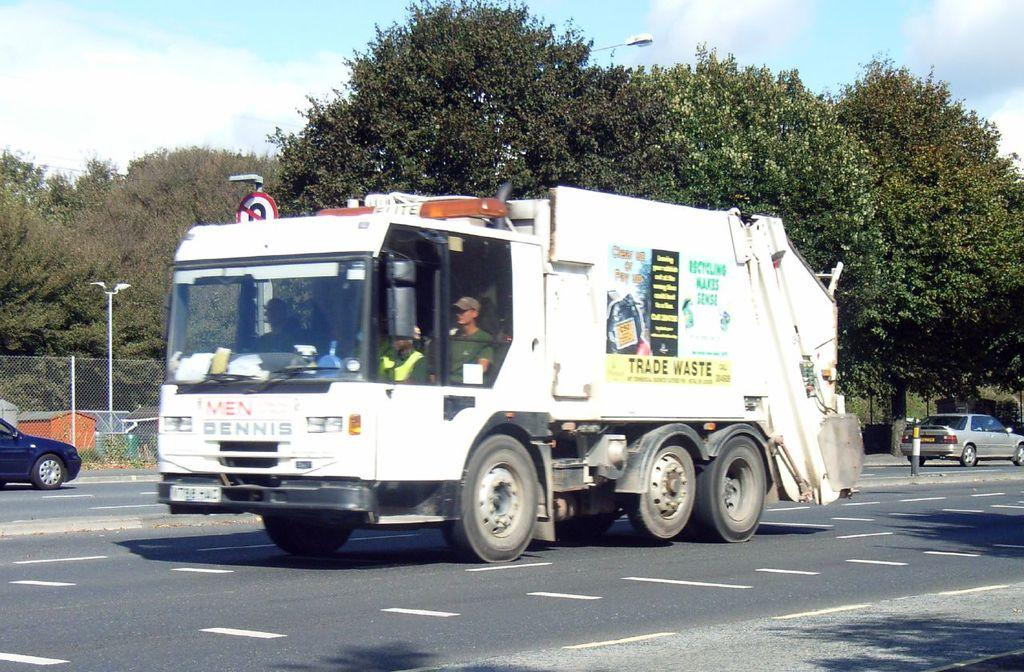What can be seen on the road in the image? There are vehicles on the road in the image. Are there any people visible in the vehicles? Yes, people are visible in at least one vehicle. What can be seen in the background of the image? There are light poles, a mesh, houses, trees, and a cloudy sky visible in the background. Can you see a rat running across the mesh in the background? There is no rat visible in the image, and the mesh is in the background, not the foreground. 